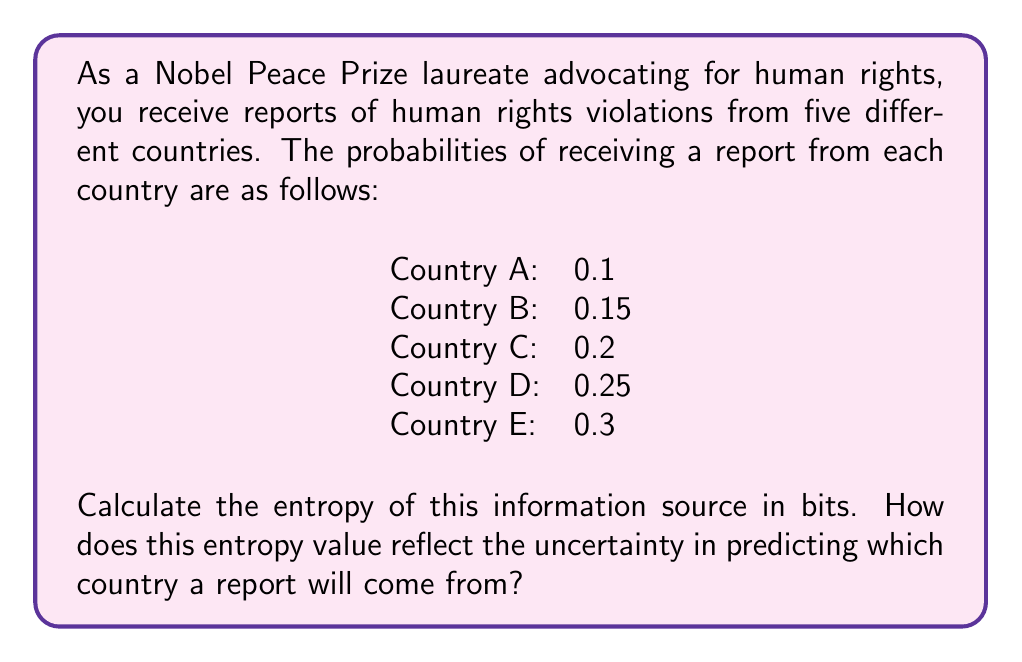Show me your answer to this math problem. To calculate the entropy of this information source, we'll use Shannon's entropy formula:

$$H = -\sum_{i=1}^{n} p_i \log_2(p_i)$$

Where $H$ is the entropy, $p_i$ is the probability of each event, and $n$ is the number of possible events.

Let's calculate each term:

1. For Country A: $-0.1 \log_2(0.1) = 0.332$
2. For Country B: $-0.15 \log_2(0.15) = 0.411$
3. For Country C: $-0.2 \log_2(0.2) = 0.464$
4. For Country D: $-0.25 \log_2(0.25) = 0.5$
5. For Country E: $-0.3 \log_2(0.3) = 0.521$

Now, we sum these values:

$$H = 0.332 + 0.411 + 0.464 + 0.5 + 0.521 = 2.228\text{ bits}$$

This entropy value reflects the uncertainty in predicting which country a report will come from. A higher entropy indicates greater uncertainty or unpredictability. The maximum entropy for a system with 5 equally likely outcomes would be $\log_2(5) \approx 2.322$ bits. Our calculated value of 2.228 bits is close to this maximum, indicating a high degree of uncertainty in predicting the source of a report.

The entropy being close to the maximum suggests that the distribution of reports is relatively even across the countries, which aligns with the goal of comprehensive human rights monitoring. However, there is still some predictability, as the probabilities are not exactly equal.
Answer: The entropy of the information source is 2.228 bits. 